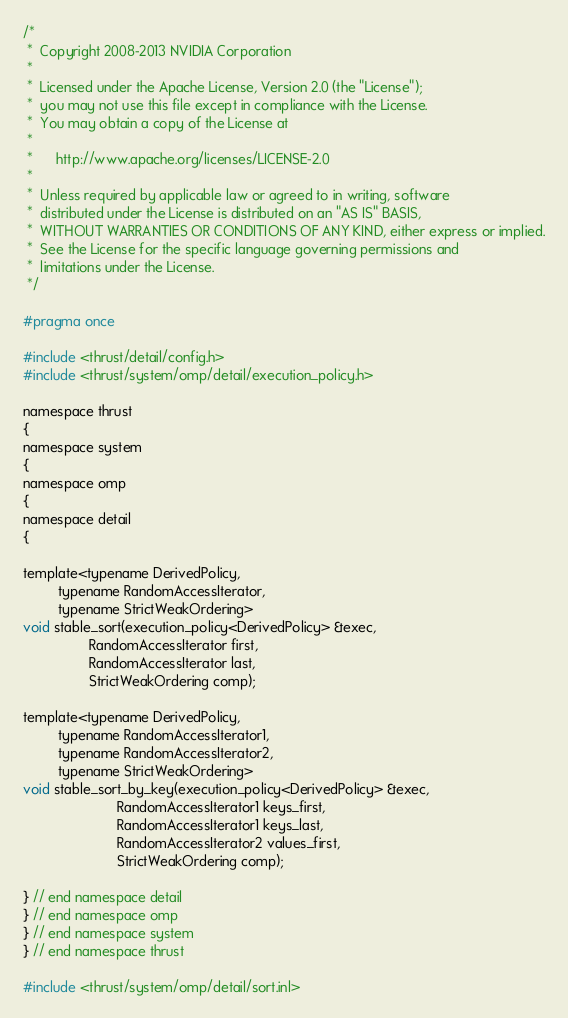Convert code to text. <code><loc_0><loc_0><loc_500><loc_500><_C_>/*
 *  Copyright 2008-2013 NVIDIA Corporation
 *
 *  Licensed under the Apache License, Version 2.0 (the "License");
 *  you may not use this file except in compliance with the License.
 *  You may obtain a copy of the License at
 *
 *      http://www.apache.org/licenses/LICENSE-2.0
 *
 *  Unless required by applicable law or agreed to in writing, software
 *  distributed under the License is distributed on an "AS IS" BASIS,
 *  WITHOUT WARRANTIES OR CONDITIONS OF ANY KIND, either express or implied.
 *  See the License for the specific language governing permissions and
 *  limitations under the License.
 */

#pragma once

#include <thrust/detail/config.h>
#include <thrust/system/omp/detail/execution_policy.h>

namespace thrust
{
namespace system
{
namespace omp
{
namespace detail
{

template<typename DerivedPolicy,
         typename RandomAccessIterator,
         typename StrictWeakOrdering>
void stable_sort(execution_policy<DerivedPolicy> &exec,
                 RandomAccessIterator first,
                 RandomAccessIterator last,
                 StrictWeakOrdering comp);
    
template<typename DerivedPolicy,
         typename RandomAccessIterator1,
         typename RandomAccessIterator2,
         typename StrictWeakOrdering>
void stable_sort_by_key(execution_policy<DerivedPolicy> &exec,
                        RandomAccessIterator1 keys_first,
                        RandomAccessIterator1 keys_last,
                        RandomAccessIterator2 values_first,
                        StrictWeakOrdering comp);

} // end namespace detail
} // end namespace omp
} // end namespace system
} // end namespace thrust

#include <thrust/system/omp/detail/sort.inl>

</code> 